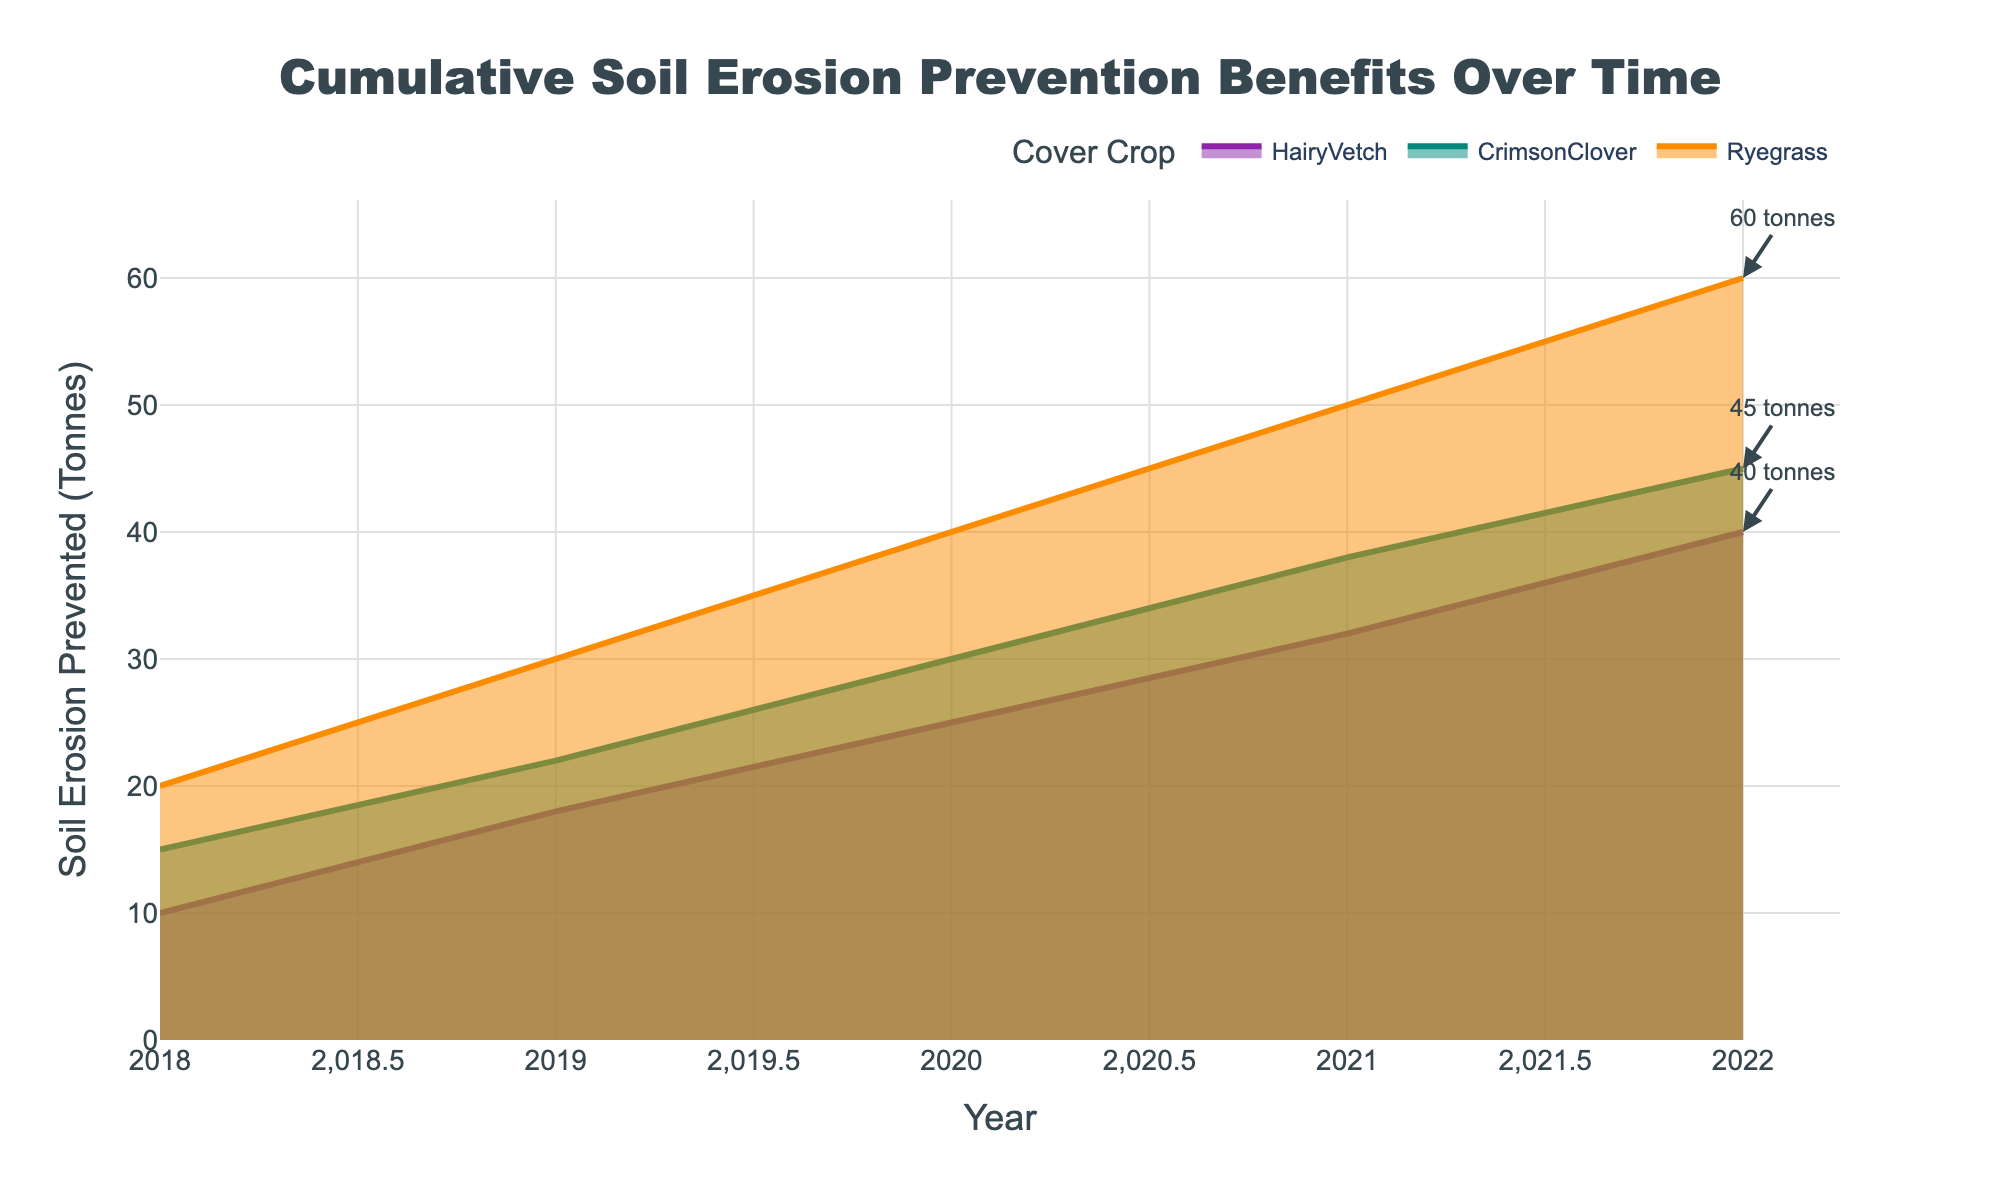What is the title of the chart? The title of the chart is usually found at the top, centered. By looking at the figure, you can see the text that summarizes the chart's main topic.
Answer: Cumulative Soil Erosion Prevention Benefits Over Time What are the units used for the y-axis? The units on the y-axis indicate the measurement used for soil erosion prevention. You can find this information by checking the text label on the y-axis.
Answer: Tonnes Which cover crop had the highest soil erosion prevention in 2022? To find this, look at the data points for 2022 and compare the y-values for each cover crop. The cover crop with the highest y-value in 2022 is the one with the highest soil erosion prevention.
Answer: Ryegrass How has the soil erosion prevention for Hairy Vetch changed from 2018 to 2022? To answer this, examine the y-values for Hairy Vetch at the years 2018 and 2022, then calculate the difference.
Answer: Increased by 30 tonnes Between 2018 and 2022, which year had the largest increase in soil erosion prevention for Crimson Clover? Look at the yearly values for Crimson Clover and calculate the differences between consecutive years. The year with the largest increase will have the highest difference.
Answer: 2019 What is the total soil erosion prevented by Ryegrass over the years shown in the chart? Sum the y-values for Ryegrass for all years from 2018 to 2022.
Answer: 200 tonnes Which cover crop consistently showed the least soil erosion prevention over the years? Compare the y-values for each cover crop year by year and identify the crop that consistently has the lowest values.
Answer: Hairy Vetch By how much did the soil erosion prevention for Ryegrass increase from 2019 to 2021? Subtract the y-value of Ryegrass in 2019 from the y-value in 2021 to calculate the increase.
Answer: 20 tonnes Which year had the smallest overall soil erosion prevented by all cover crops combined? Sum the y-values of all cover crops for each year and find the year with the smallest total.
Answer: 2018 